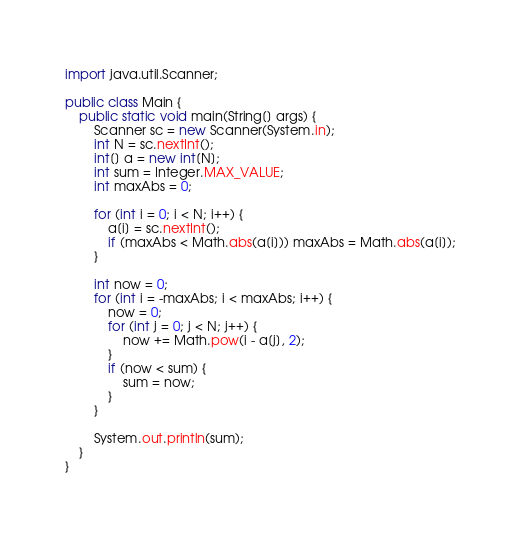<code> <loc_0><loc_0><loc_500><loc_500><_Java_>import java.util.Scanner;

public class Main {
	public static void main(String[] args) {
		Scanner sc = new Scanner(System.in);
		int N = sc.nextInt();
		int[] a = new int[N];
		int sum = Integer.MAX_VALUE;
		int maxAbs = 0;

		for (int i = 0; i < N; i++) {
			a[i] = sc.nextInt();
			if (maxAbs < Math.abs(a[i])) maxAbs = Math.abs(a[i]);
		}

		int now = 0;
		for (int i = -maxAbs; i < maxAbs; i++) {
			now = 0;
			for (int j = 0; j < N; j++) {
				now += Math.pow(i - a[j], 2);
			}
			if (now < sum) {
				sum = now;
			}
		}

		System.out.println(sum);
	}
}
</code> 